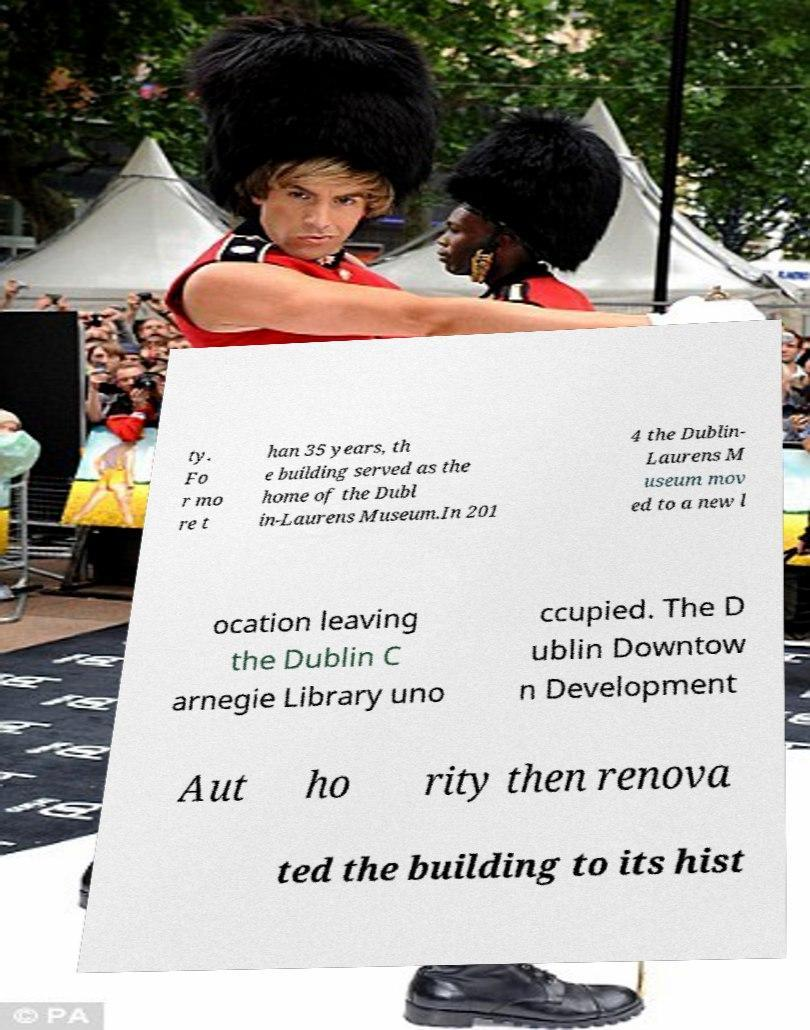Can you accurately transcribe the text from the provided image for me? ty. Fo r mo re t han 35 years, th e building served as the home of the Dubl in-Laurens Museum.In 201 4 the Dublin- Laurens M useum mov ed to a new l ocation leaving the Dublin C arnegie Library uno ccupied. The D ublin Downtow n Development Aut ho rity then renova ted the building to its hist 